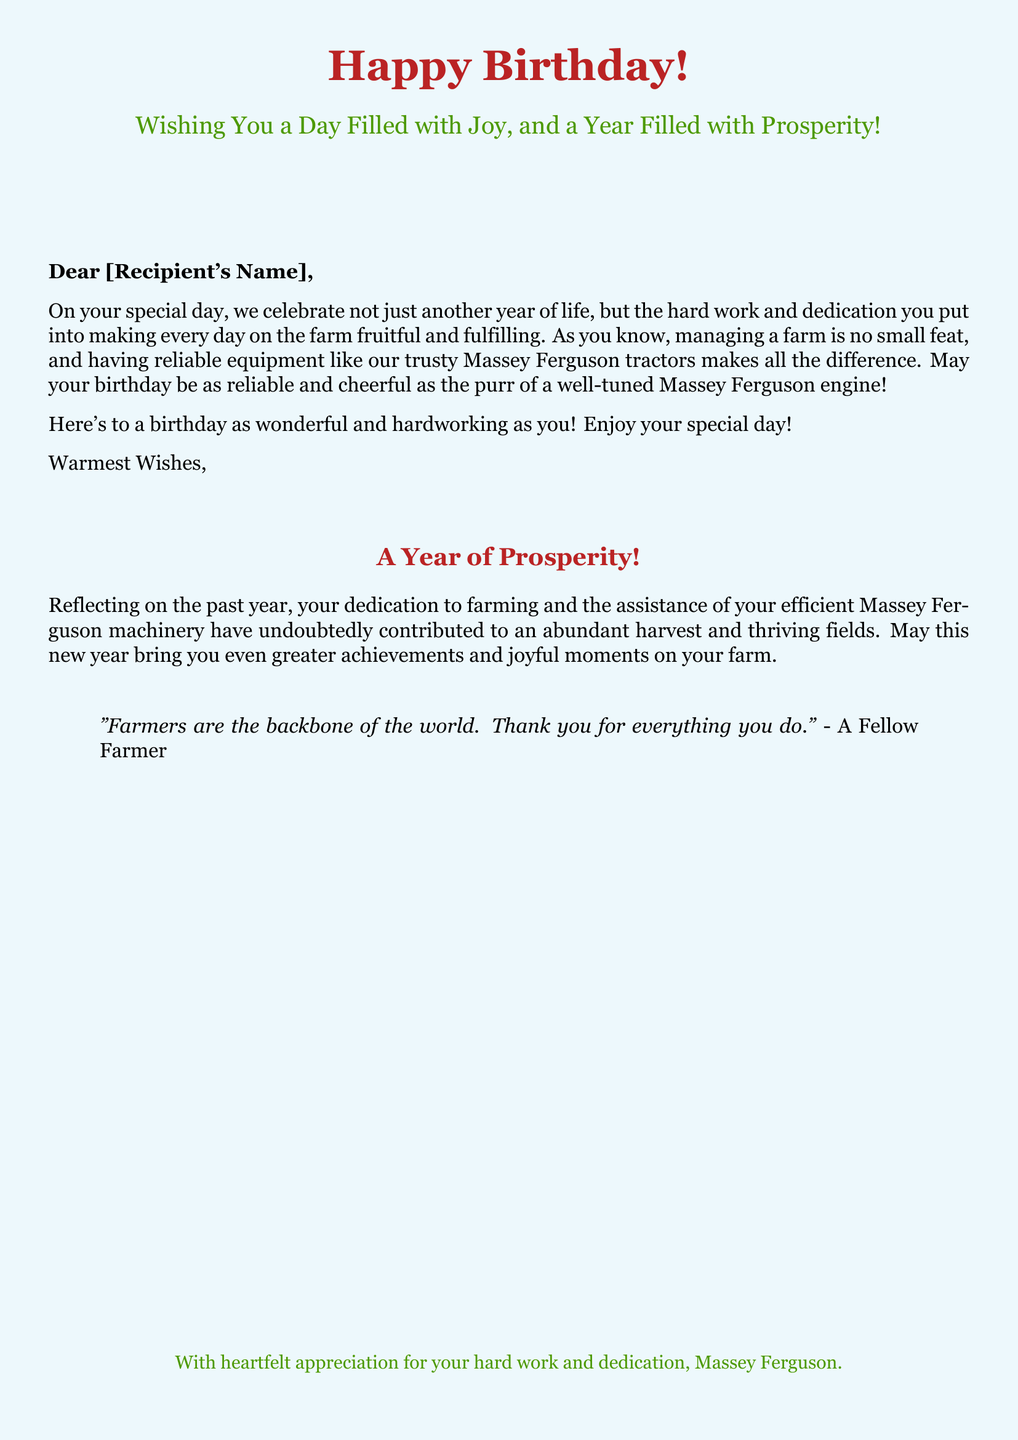What is the main greeting on the card? The main greeting is prominently displayed at the top of the card, stating "Happy Birthday!"
Answer: Happy Birthday! What color is used for the background? The background color of the document is sky blue with a blend of a lighter shade, setting a cheerful atmosphere.
Answer: skyblue What phrase follows the main greeting? The phrase following the main greeting wishes the recipient a delightful experience on their special day.
Answer: Wishing You a Day Filled with Joy, and a Year Filled with Prosperity! How does the card reference Massey Ferguson equipment? The card emphasizes the role of Massey Ferguson tractors in farming and their reliability, tying it into the birthday wishes.
Answer: reliable equipment like our trusty Massey Ferguson tractors What does the quote in the card describe? The quote accentuates the importance of farmers and expresses gratitude for their contribution to the world.
Answer: Farmers are the backbone of the world What year is being reflected upon in the card? The document reflects on the past year, highlighting the recipient's dedication to farming.
Answer: past year What is the concluding message on the card? The concluding message expresses warm wishes for another year filled with prosperity.
Answer: A Year of Prosperity! Who is the final note of appreciation from? The final note of appreciation is explicitly stated to be from Massey Ferguson.
Answer: Massey Ferguson 